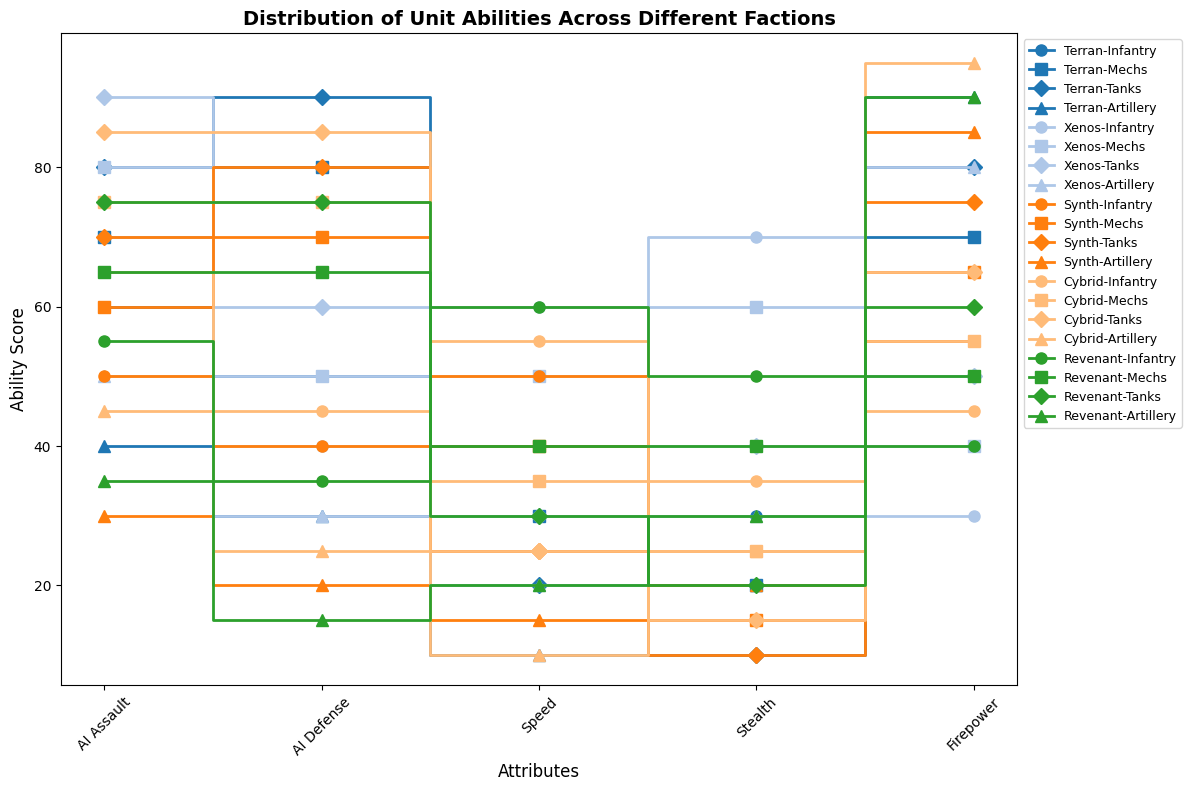What is the highest Firepower value among all units? The highest Firepower value can be observed by looking at the peaks of the stair steps in the Firepower column. The highest value appears in the Cybrid Artillery unit.
Answer: 95 Which faction's Infantry unit has the best AI Assault score? To find this, we look at the AI Assault scores for each faction's Infantry unit. The Xenos Infantry unit has an AI Assault score of 70, which is the highest among all factions.
Answer: Xenos What is the average Speed of Mechs units across all factions? We need to sum the Speed values for Mechs units from all factions and then divide by the number of Mechs units. The speeds are 30 (Terran), 50 (Xenos), 40 (Synth), 35 (Cybrid), and 40 (Revenant). Average is (30 + 50 + 40 + 35 + 40) / 5.
Answer: 39 Which faction's units have the most consistent (least variable) Firepower scores? By comparing the visual step heights in the Firepower column for each faction's units, Synth units show the least variability as their Firepower scores are relatively close (55, 65, 75, 85).
Answer: Synth Between the Terran and Xenos factions, which has the higher AI Defense score for Tanks? We compare the AI Defense scores for Tanks of the two factions. For Terran, it is 90 and for Xenos, it is 60. The Terran faction has a higher score.
Answer: Terran Among the Mechs units, which faction has the highest Stealth ability? We compare the Stealth values for Mechs units from each faction. For Mechs, the Xenos faction has the highest Stealth score of 60.
Answer: Xenos What is the difference in average AI Assault scores between Infantry and Tanks units across all factions? First, calculate the average AI Assault score for Infantry and Tanks units separately. For Infantry: (60 + 70 + 50 + 65 + 55) / 5 = 60. For Tanks: (80 + 90 + 70 + 85 + 75) / 5 = 80. The difference is 80 - 60.
Answer: 20 Which unit type has the lowest overall Stealth score across all units? By comparing the Stealth values of all unit types, Tanks have the lowest overall scores.
Answer: Tanks What is the combined AI Defense score for Cybrid Infantry, Mechs, and Artillery units? The AI Defense scores for Cybrid Infantry, Mechs, and Artillery units are 45, 75, and 25 respectively. Their combined score is 45 + 75 + 25.
Answer: 145 